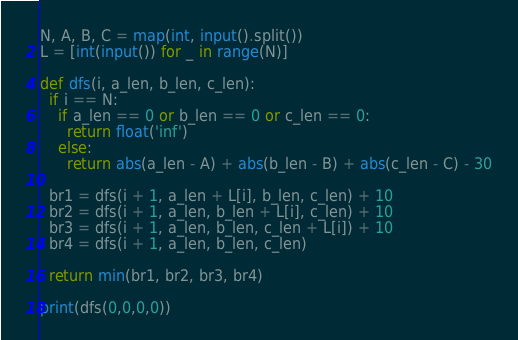Convert code to text. <code><loc_0><loc_0><loc_500><loc_500><_Python_>N, A, B, C = map(int, input().split())
L = [int(input()) for _ in range(N)]

def dfs(i, a_len, b_len, c_len):
  if i == N:
    if a_len == 0 or b_len == 0 or c_len == 0:
      return float('inf')
    else:
      return abs(a_len - A) + abs(b_len - B) + abs(c_len - C) - 30
  
  br1 = dfs(i + 1, a_len + L[i], b_len, c_len) + 10
  br2 = dfs(i + 1, a_len, b_len + L[i], c_len) + 10
  br3 = dfs(i + 1, a_len, b_len, c_len + L[i]) + 10
  br4 = dfs(i + 1, a_len, b_len, c_len)
  
  return min(br1, br2, br3, br4)

print(dfs(0,0,0,0))
</code> 